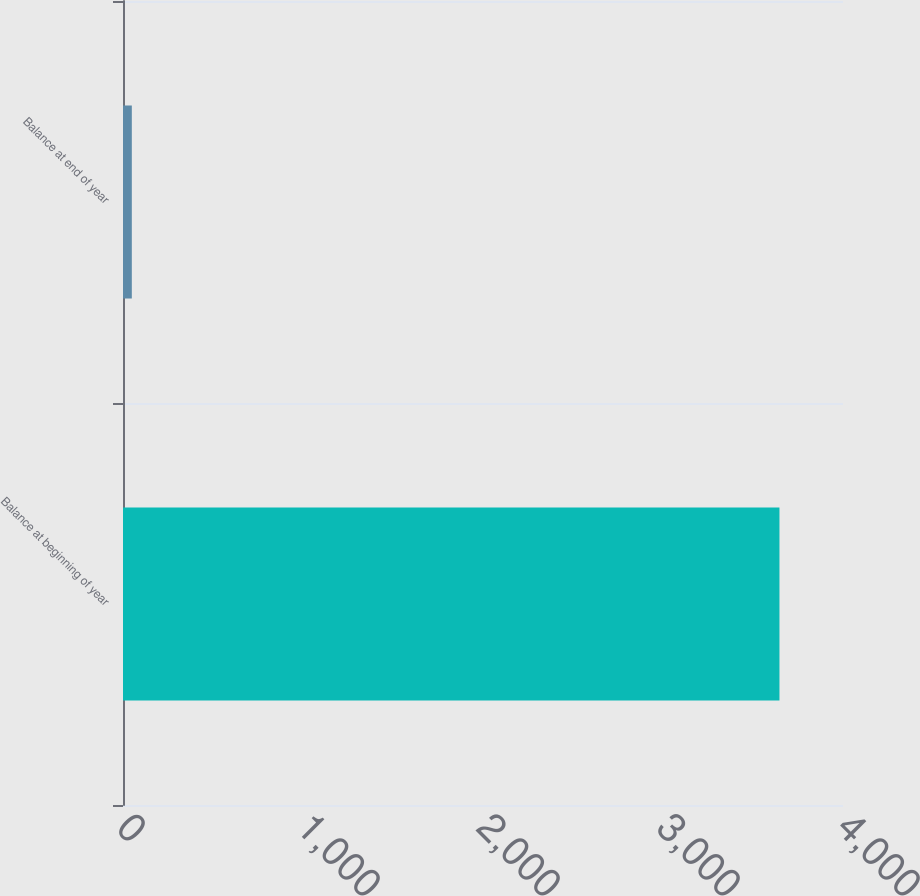Convert chart to OTSL. <chart><loc_0><loc_0><loc_500><loc_500><bar_chart><fcel>Balance at beginning of year<fcel>Balance at end of year<nl><fcel>3647<fcel>49<nl></chart> 